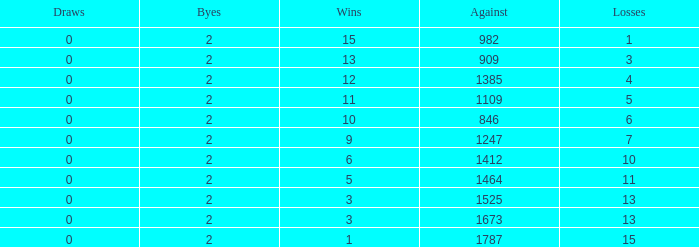What is the number listed under against when there were less than 13 losses and less than 2 byes? 0.0. 